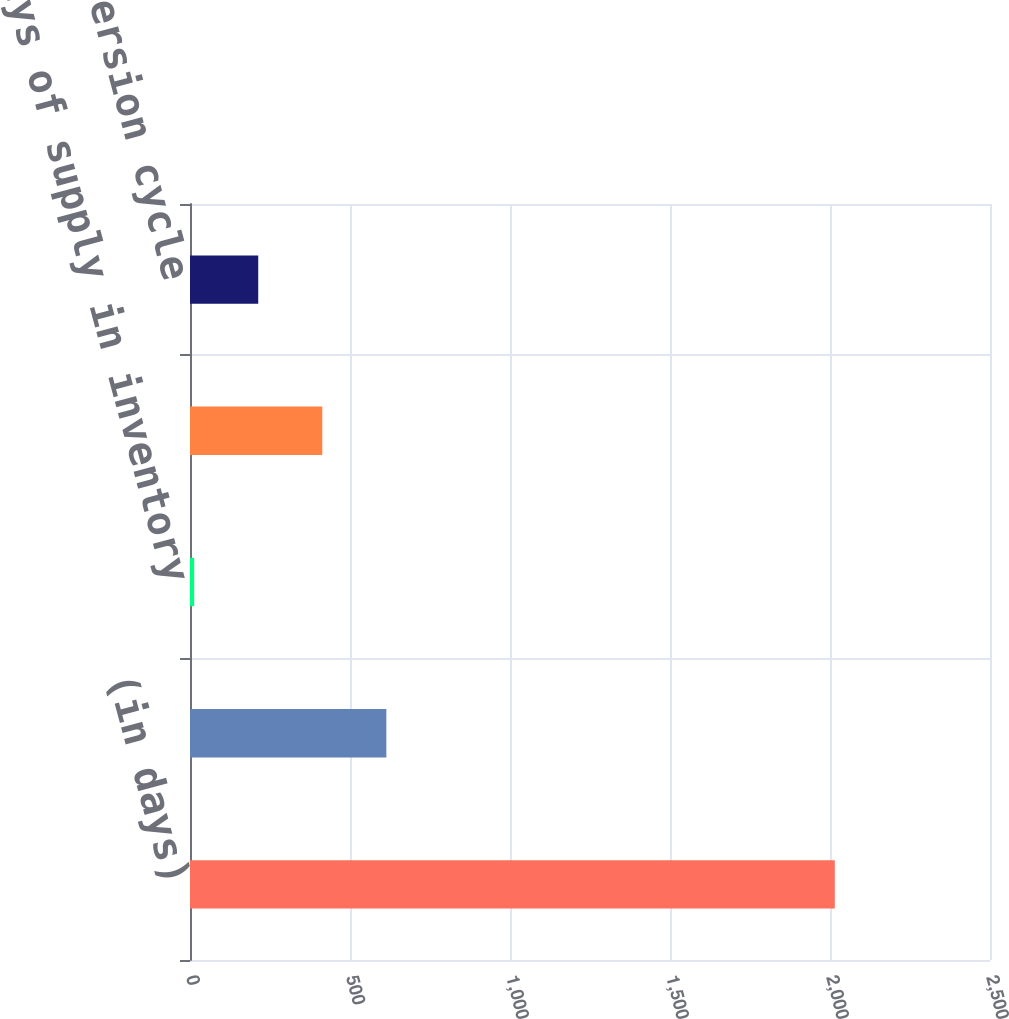Convert chart to OTSL. <chart><loc_0><loc_0><loc_500><loc_500><bar_chart><fcel>(in days)<fcel>Days of sales outstanding<fcel>Days of supply in inventory<fcel>Days of purchases outstanding<fcel>Cash conversion cycle<nl><fcel>2015<fcel>613.6<fcel>13<fcel>413.4<fcel>213.2<nl></chart> 